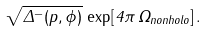Convert formula to latex. <formula><loc_0><loc_0><loc_500><loc_500>\sqrt { \Delta ^ { - } ( p , \phi ) } \, \exp [ 4 \pi \, \Omega _ { n o n h o l o } ] \, .</formula> 